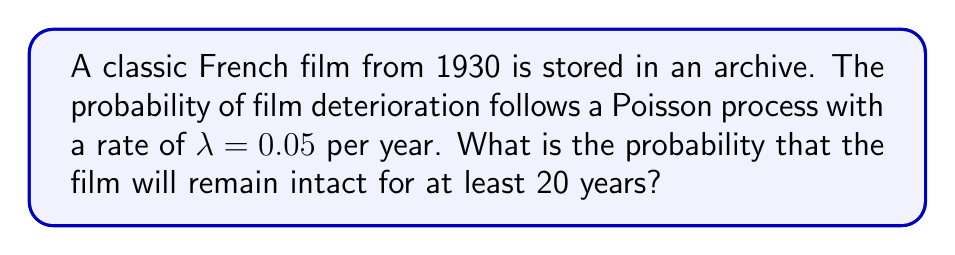Can you answer this question? Let's approach this step-by-step:

1) The Poisson process is a model for rare events occurring over time. In this case, the "event" is film deterioration.

2) The probability of no events occurring in a time interval $t$ for a Poisson process with rate $\lambda$ is given by:

   $$P(N(t) = 0) = e^{-\lambda t}$$

   Where $N(t)$ is the number of events in time $t$.

3) In our case:
   - $\lambda = 0.05$ per year
   - $t = 20$ years

4) Substituting these values into the formula:

   $$P(N(20) = 0) = e^{-0.05 * 20}$$

5) Simplifying:

   $$P(N(20) = 0) = e^{-1}$$

6) Calculating:

   $$P(N(20) = 0) \approx 0.3679$$

This means there's approximately a 36.79% chance that the film will remain intact for at least 20 years.
Answer: $e^{-1} \approx 0.3679$ 